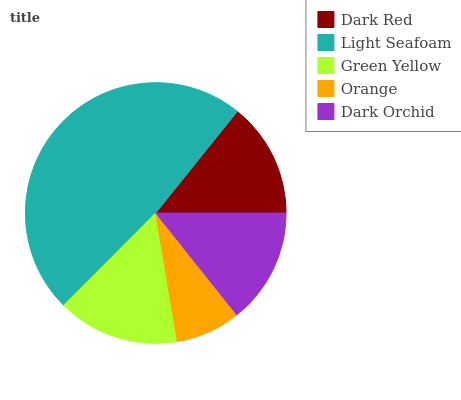Is Orange the minimum?
Answer yes or no. Yes. Is Light Seafoam the maximum?
Answer yes or no. Yes. Is Green Yellow the minimum?
Answer yes or no. No. Is Green Yellow the maximum?
Answer yes or no. No. Is Light Seafoam greater than Green Yellow?
Answer yes or no. Yes. Is Green Yellow less than Light Seafoam?
Answer yes or no. Yes. Is Green Yellow greater than Light Seafoam?
Answer yes or no. No. Is Light Seafoam less than Green Yellow?
Answer yes or no. No. Is Dark Orchid the high median?
Answer yes or no. Yes. Is Dark Orchid the low median?
Answer yes or no. Yes. Is Dark Red the high median?
Answer yes or no. No. Is Dark Red the low median?
Answer yes or no. No. 